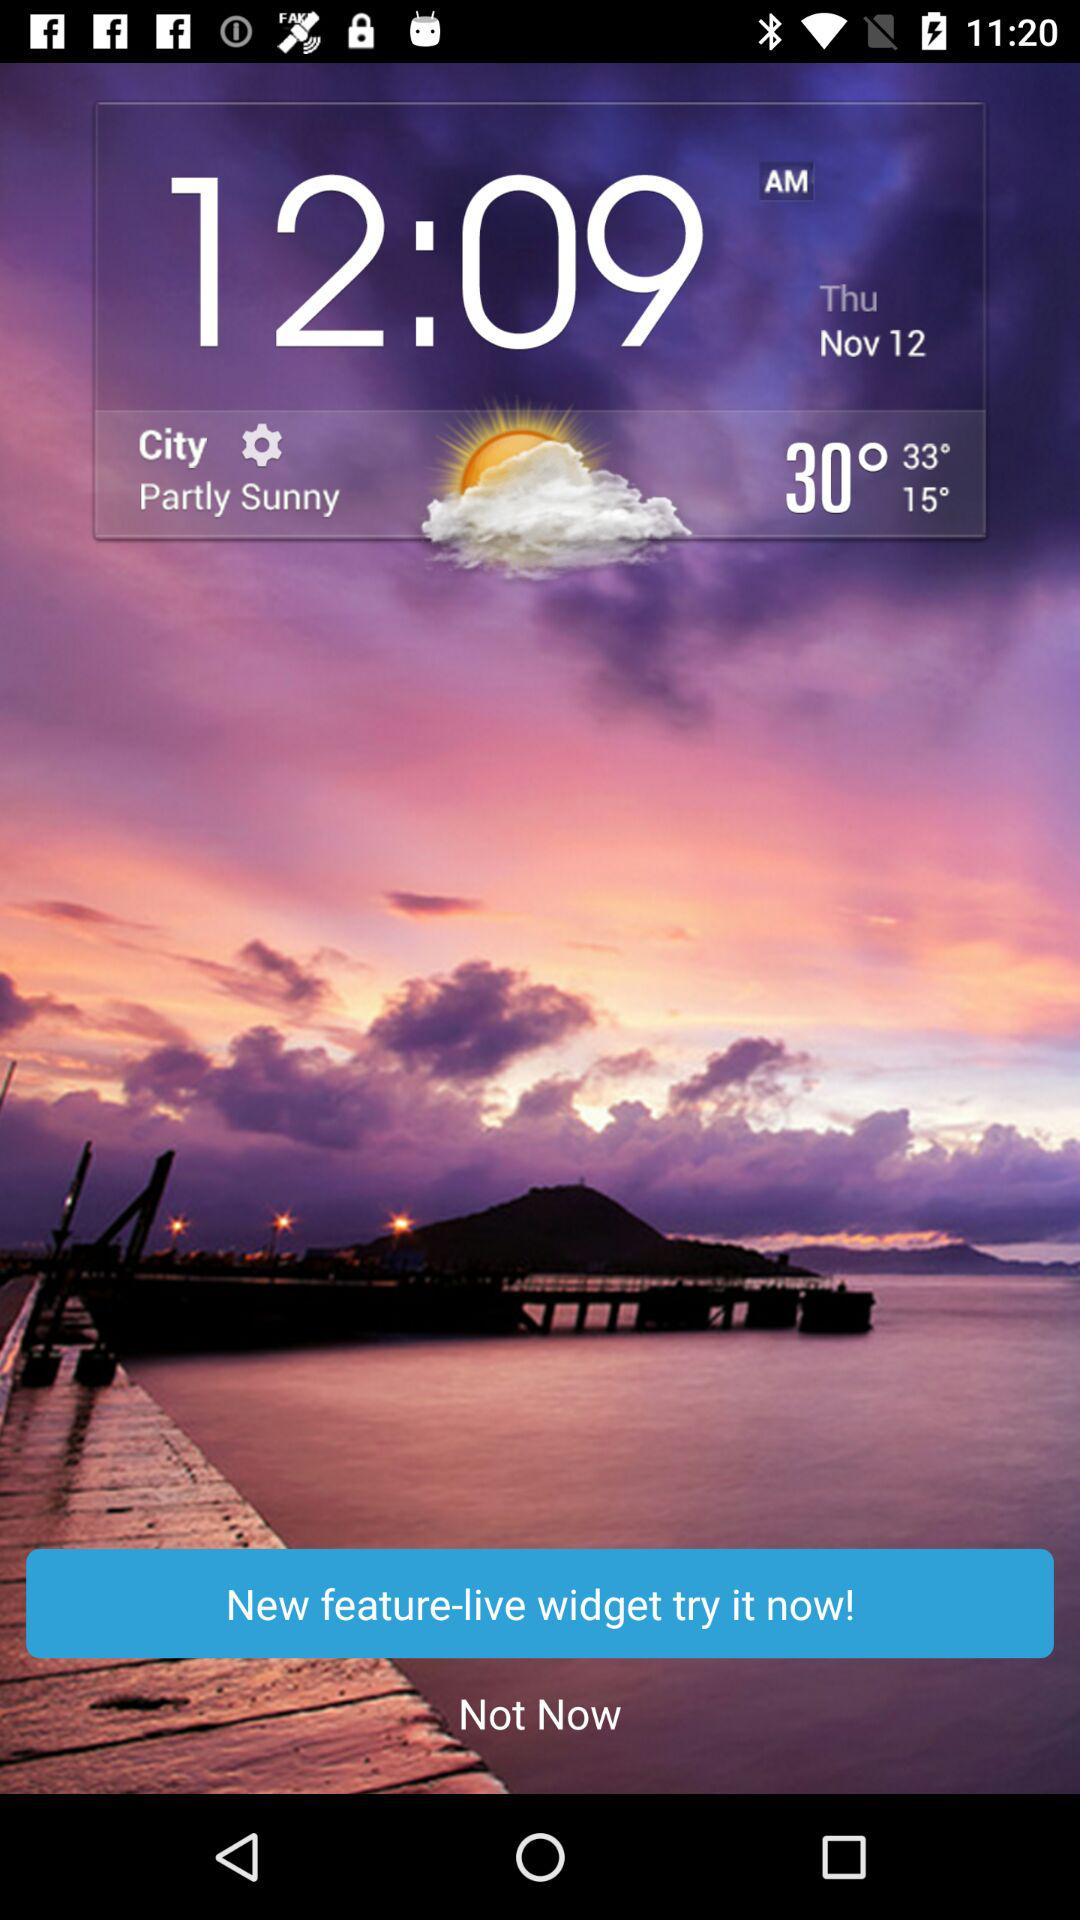What is the temperature? The temperature is 30°. 